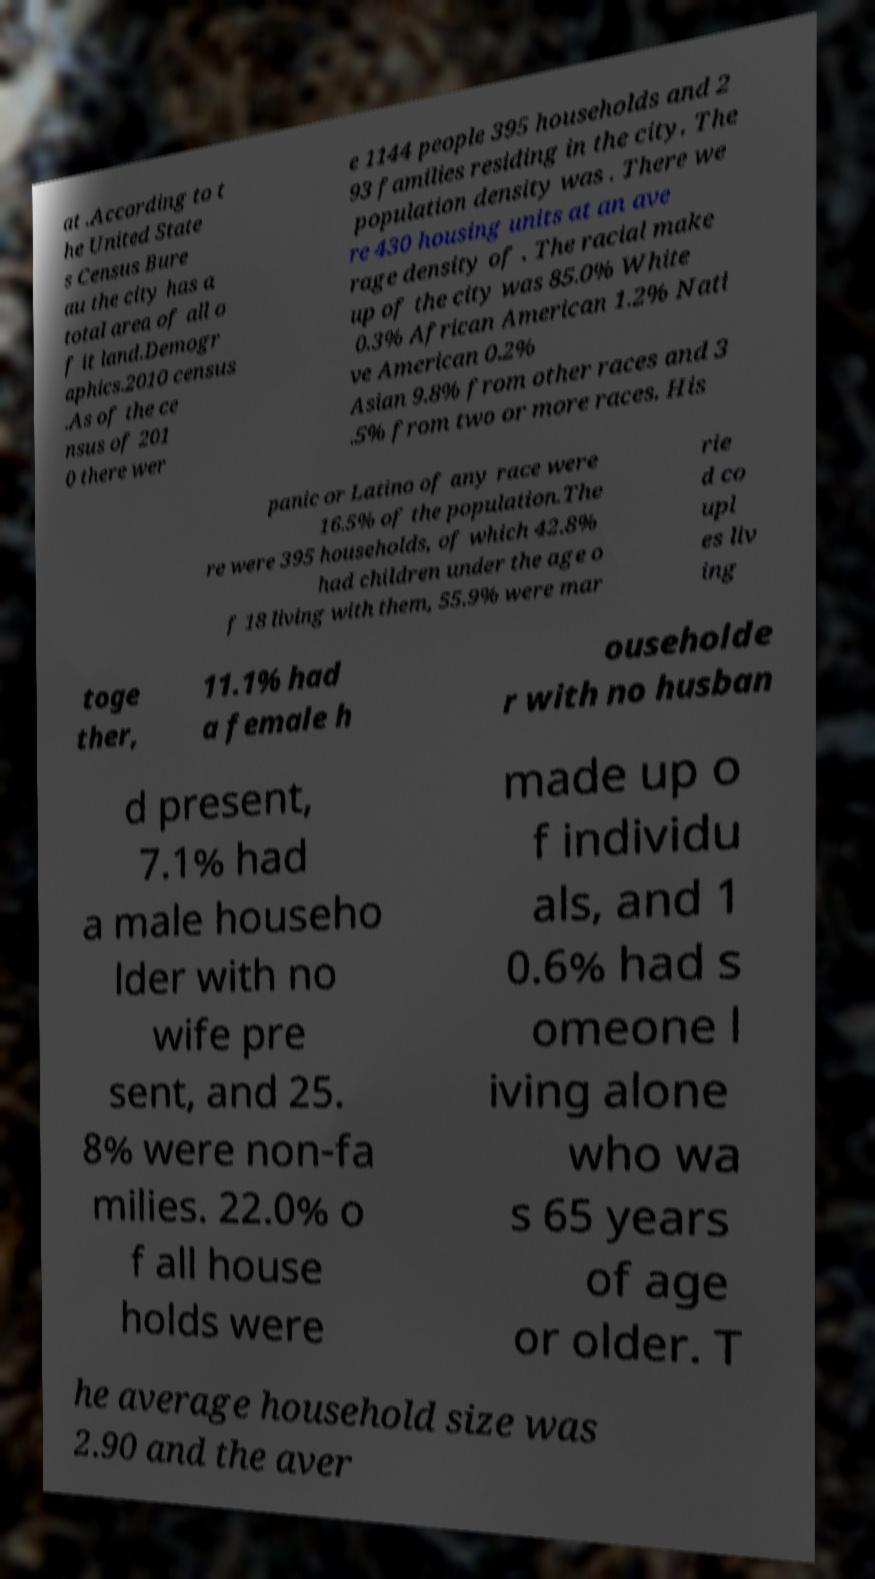For documentation purposes, I need the text within this image transcribed. Could you provide that? at .According to t he United State s Census Bure au the city has a total area of all o f it land.Demogr aphics.2010 census .As of the ce nsus of 201 0 there wer e 1144 people 395 households and 2 93 families residing in the city. The population density was . There we re 430 housing units at an ave rage density of . The racial make up of the city was 85.0% White 0.3% African American 1.2% Nati ve American 0.2% Asian 9.8% from other races and 3 .5% from two or more races. His panic or Latino of any race were 16.5% of the population.The re were 395 households, of which 42.8% had children under the age o f 18 living with them, 55.9% were mar rie d co upl es liv ing toge ther, 11.1% had a female h ouseholde r with no husban d present, 7.1% had a male househo lder with no wife pre sent, and 25. 8% were non-fa milies. 22.0% o f all house holds were made up o f individu als, and 1 0.6% had s omeone l iving alone who wa s 65 years of age or older. T he average household size was 2.90 and the aver 